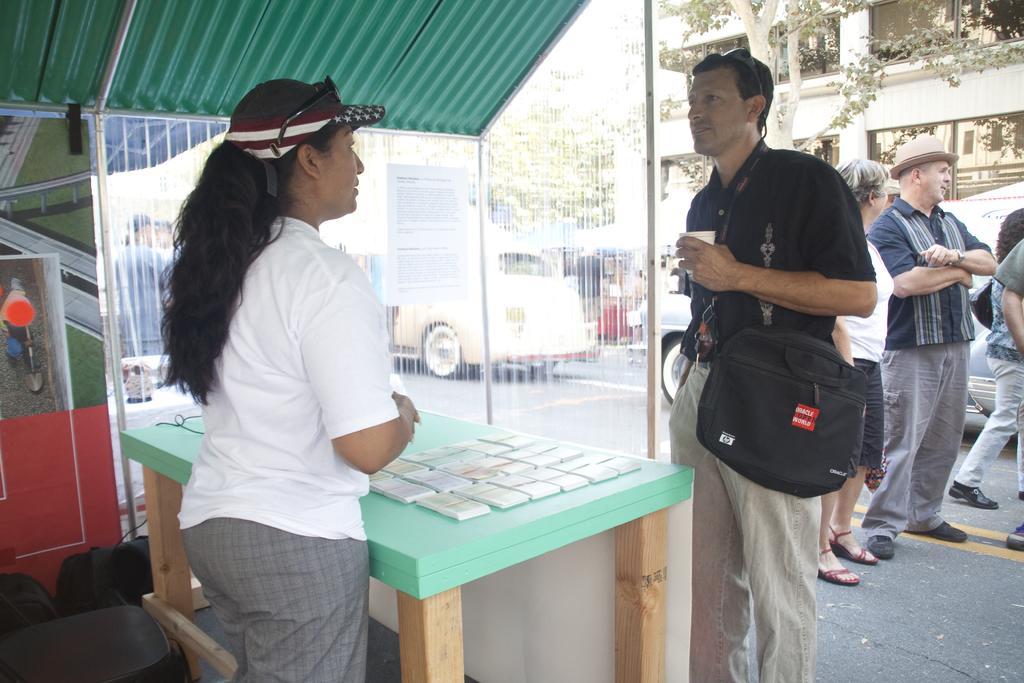Could you give a brief overview of what you see in this image? in this picture we can see group of people, a man is holding a cup in his hand and he is wearing a backpack, in front of him we can find couple of papers on the table, in the background we can see few vehicles on the road, and also we can see couple of buildings and trees, 